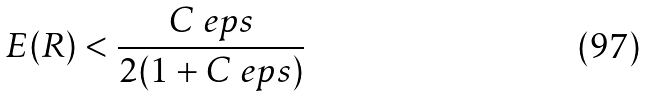<formula> <loc_0><loc_0><loc_500><loc_500>E ( R ) < \frac { C _ { \ } e p s } { 2 ( 1 + C _ { \ } e p s ) }</formula> 